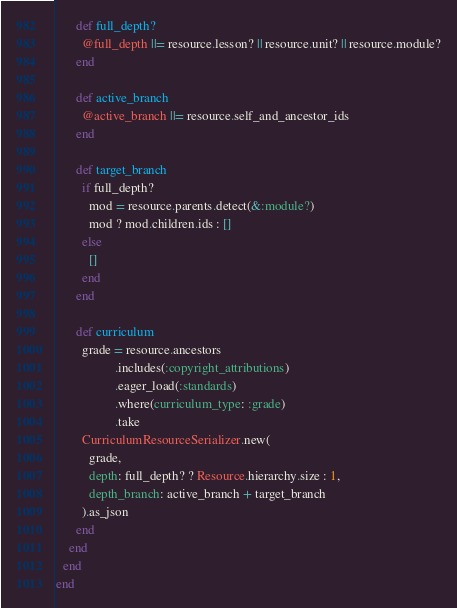<code> <loc_0><loc_0><loc_500><loc_500><_Ruby_>      def full_depth?
        @full_depth ||= resource.lesson? || resource.unit? || resource.module?
      end

      def active_branch
        @active_branch ||= resource.self_and_ancestor_ids
      end

      def target_branch
        if full_depth?
          mod = resource.parents.detect(&:module?)
          mod ? mod.children.ids : []
        else
          []
        end
      end

      def curriculum
        grade = resource.ancestors
                  .includes(:copyright_attributions)
                  .eager_load(:standards)
                  .where(curriculum_type: :grade)
                  .take
        CurriculumResourceSerializer.new(
          grade,
          depth: full_depth? ? Resource.hierarchy.size : 1,
          depth_branch: active_branch + target_branch
        ).as_json
      end
    end
  end
end
</code> 